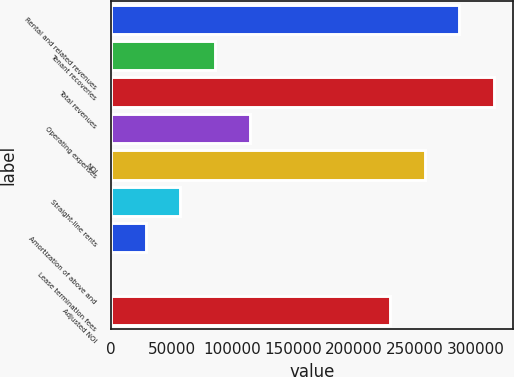<chart> <loc_0><loc_0><loc_500><loc_500><bar_chart><fcel>Rental and related revenues<fcel>Tenant recoveries<fcel>Total revenues<fcel>Operating expenses<fcel>NOI<fcel>Straight-line rents<fcel>Amortization of above and<fcel>Lease termination fees<fcel>Adjusted NOI<nl><fcel>286509<fcel>85812.4<fcel>315054<fcel>114358<fcel>257963<fcel>57266.6<fcel>28720.8<fcel>175<fcel>229417<nl></chart> 